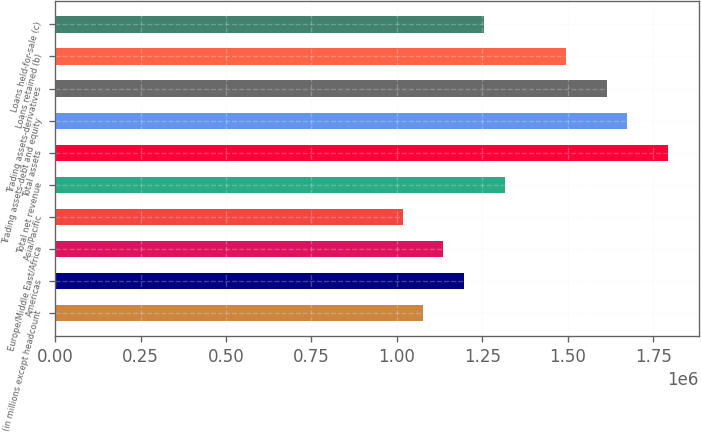Convert chart. <chart><loc_0><loc_0><loc_500><loc_500><bar_chart><fcel>(in millions except headcount<fcel>Americas<fcel>Europe/Middle East/Africa<fcel>Asia/Pacific<fcel>Total net revenue<fcel>Total assets<fcel>Trading assets-debt and equity<fcel>Trading assets-derivatives<fcel>Loans retained (b)<fcel>Loans held-for-sale (c)<nl><fcel>1.07661e+06<fcel>1.19624e+06<fcel>1.13642e+06<fcel>1.0168e+06<fcel>1.31586e+06<fcel>1.79435e+06<fcel>1.67473e+06<fcel>1.61492e+06<fcel>1.49529e+06<fcel>1.25605e+06<nl></chart> 